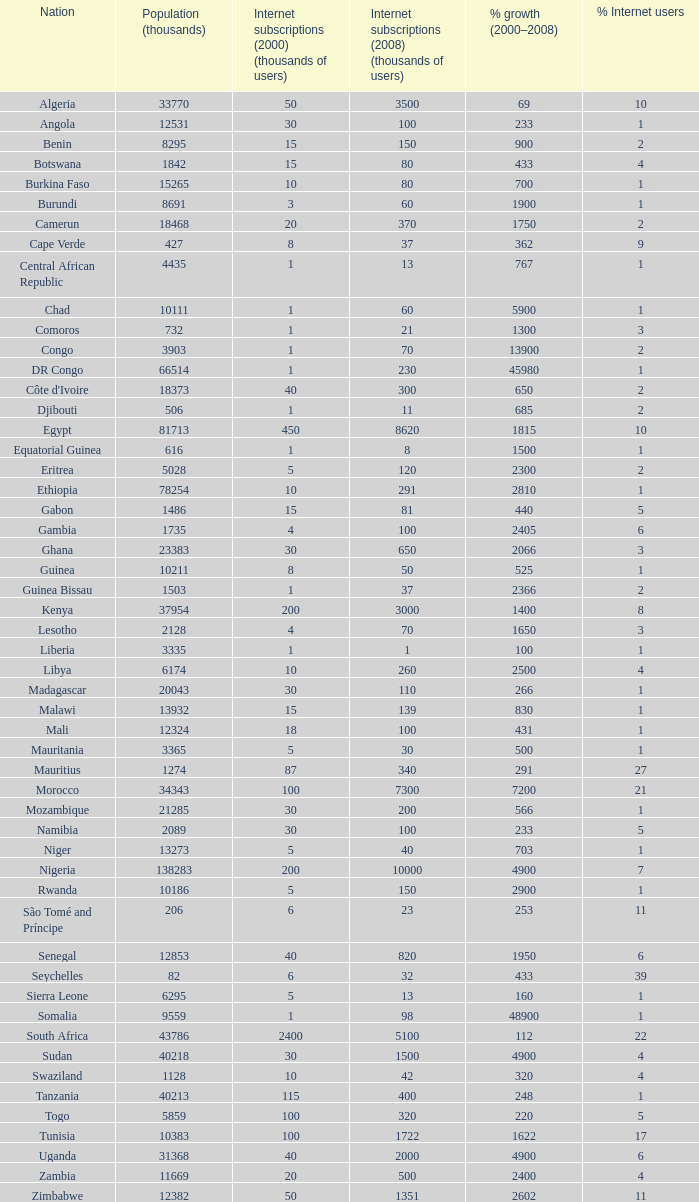What is the percentage of growth in 2000-2008 in ethiopia? 2810.0. Parse the full table. {'header': ['Nation', 'Population (thousands)', 'Internet subscriptions (2000) (thousands of users)', 'Internet subscriptions (2008) (thousands of users)', '% growth (2000–2008)', '% Internet users'], 'rows': [['Algeria', '33770', '50', '3500', '69', '10'], ['Angola', '12531', '30', '100', '233', '1'], ['Benin', '8295', '15', '150', '900', '2'], ['Botswana', '1842', '15', '80', '433', '4'], ['Burkina Faso', '15265', '10', '80', '700', '1'], ['Burundi', '8691', '3', '60', '1900', '1'], ['Camerun', '18468', '20', '370', '1750', '2'], ['Cape Verde', '427', '8', '37', '362', '9'], ['Central African Republic', '4435', '1', '13', '767', '1'], ['Chad', '10111', '1', '60', '5900', '1'], ['Comoros', '732', '1', '21', '1300', '3'], ['Congo', '3903', '1', '70', '13900', '2'], ['DR Congo', '66514', '1', '230', '45980', '1'], ["Côte d'Ivoire", '18373', '40', '300', '650', '2'], ['Djibouti', '506', '1', '11', '685', '2'], ['Egypt', '81713', '450', '8620', '1815', '10'], ['Equatorial Guinea', '616', '1', '8', '1500', '1'], ['Eritrea', '5028', '5', '120', '2300', '2'], ['Ethiopia', '78254', '10', '291', '2810', '1'], ['Gabon', '1486', '15', '81', '440', '5'], ['Gambia', '1735', '4', '100', '2405', '6'], ['Ghana', '23383', '30', '650', '2066', '3'], ['Guinea', '10211', '8', '50', '525', '1'], ['Guinea Bissau', '1503', '1', '37', '2366', '2'], ['Kenya', '37954', '200', '3000', '1400', '8'], ['Lesotho', '2128', '4', '70', '1650', '3'], ['Liberia', '3335', '1', '1', '100', '1'], ['Libya', '6174', '10', '260', '2500', '4'], ['Madagascar', '20043', '30', '110', '266', '1'], ['Malawi', '13932', '15', '139', '830', '1'], ['Mali', '12324', '18', '100', '431', '1'], ['Mauritania', '3365', '5', '30', '500', '1'], ['Mauritius', '1274', '87', '340', '291', '27'], ['Morocco', '34343', '100', '7300', '7200', '21'], ['Mozambique', '21285', '30', '200', '566', '1'], ['Namibia', '2089', '30', '100', '233', '5'], ['Niger', '13273', '5', '40', '703', '1'], ['Nigeria', '138283', '200', '10000', '4900', '7'], ['Rwanda', '10186', '5', '150', '2900', '1'], ['São Tomé and Príncipe', '206', '6', '23', '253', '11'], ['Senegal', '12853', '40', '820', '1950', '6'], ['Seychelles', '82', '6', '32', '433', '39'], ['Sierra Leone', '6295', '5', '13', '160', '1'], ['Somalia', '9559', '1', '98', '48900', '1'], ['South Africa', '43786', '2400', '5100', '112', '22'], ['Sudan', '40218', '30', '1500', '4900', '4'], ['Swaziland', '1128', '10', '42', '320', '4'], ['Tanzania', '40213', '115', '400', '248', '1'], ['Togo', '5859', '100', '320', '220', '5'], ['Tunisia', '10383', '100', '1722', '1622', '17'], ['Uganda', '31368', '40', '2000', '4900', '6'], ['Zambia', '11669', '20', '500', '2400', '4'], ['Zimbabwe', '12382', '50', '1351', '2602', '11']]} 